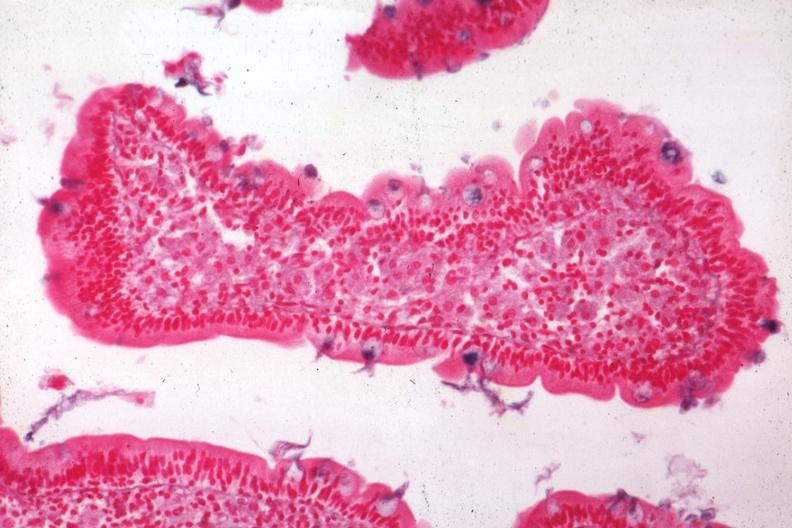s this good yellow color slide present?
Answer the question using a single word or phrase. No 